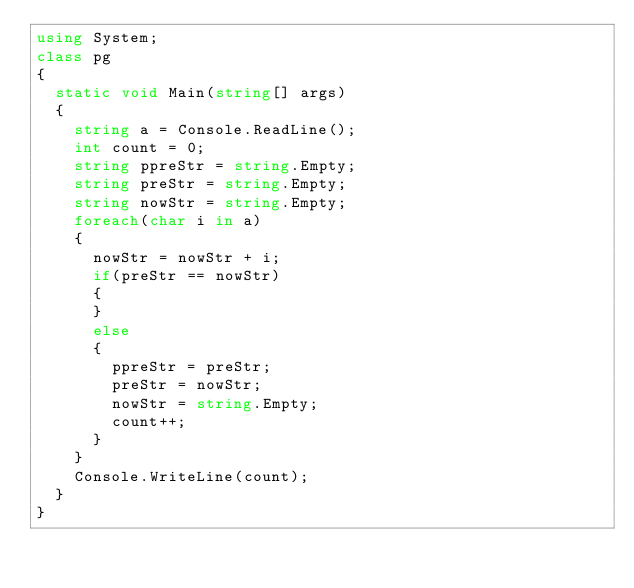<code> <loc_0><loc_0><loc_500><loc_500><_C#_>using System;
class pg
{
  static void Main(string[] args)
  {
    string a = Console.ReadLine();
    int count = 0;
    string ppreStr = string.Empty;
    string preStr = string.Empty;
    string nowStr = string.Empty;
    foreach(char i in a)
    {
      nowStr = nowStr + i;
      if(preStr == nowStr)
      {
      }
      else
      {
        ppreStr = preStr;
        preStr = nowStr;
        nowStr = string.Empty;
        count++;
      }
    }
    Console.WriteLine(count);
  }
}
</code> 